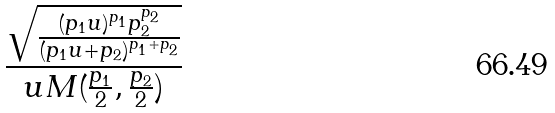Convert formula to latex. <formula><loc_0><loc_0><loc_500><loc_500>\frac { \sqrt { \frac { ( p _ { 1 } u ) ^ { p _ { 1 } } p _ { 2 } ^ { p _ { 2 } } } { ( p _ { 1 } u + p _ { 2 } ) ^ { p _ { 1 } + p _ { 2 } } } } } { u M ( \frac { p _ { 1 } } { 2 } , \frac { p _ { 2 } } { 2 } ) }</formula> 